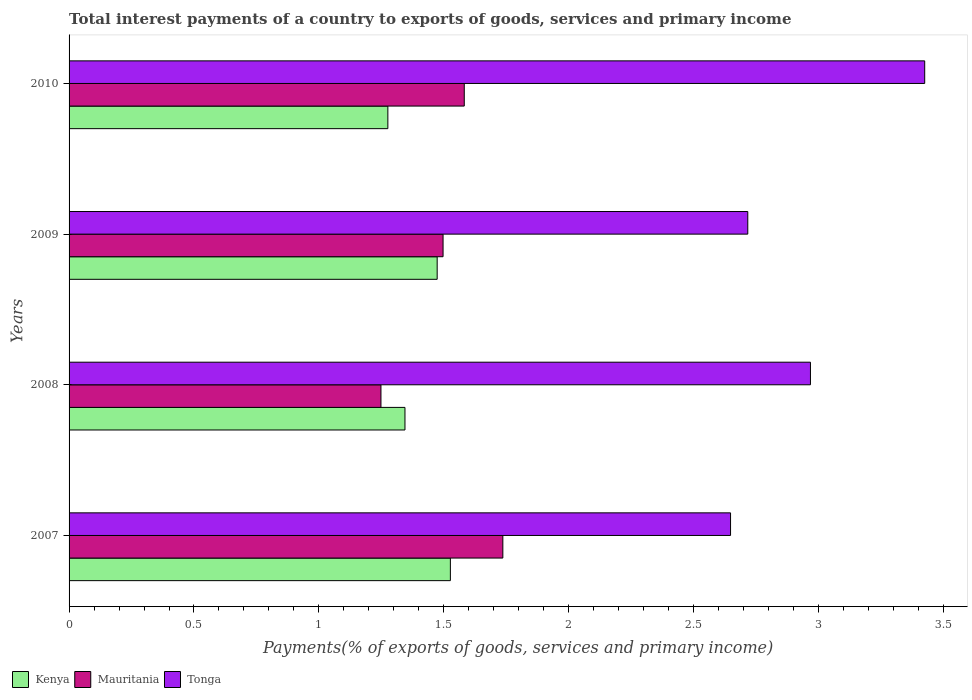How many different coloured bars are there?
Your response must be concise. 3. How many groups of bars are there?
Ensure brevity in your answer.  4. Are the number of bars per tick equal to the number of legend labels?
Give a very brief answer. Yes. Are the number of bars on each tick of the Y-axis equal?
Your answer should be very brief. Yes. How many bars are there on the 4th tick from the bottom?
Provide a succinct answer. 3. In how many cases, is the number of bars for a given year not equal to the number of legend labels?
Ensure brevity in your answer.  0. What is the total interest payments in Tonga in 2010?
Offer a very short reply. 3.43. Across all years, what is the maximum total interest payments in Kenya?
Offer a terse response. 1.53. Across all years, what is the minimum total interest payments in Tonga?
Your response must be concise. 2.65. In which year was the total interest payments in Kenya maximum?
Give a very brief answer. 2007. In which year was the total interest payments in Mauritania minimum?
Provide a short and direct response. 2008. What is the total total interest payments in Kenya in the graph?
Your response must be concise. 5.62. What is the difference between the total interest payments in Kenya in 2007 and that in 2008?
Ensure brevity in your answer.  0.18. What is the difference between the total interest payments in Tonga in 2010 and the total interest payments in Kenya in 2009?
Offer a very short reply. 1.95. What is the average total interest payments in Mauritania per year?
Give a very brief answer. 1.52. In the year 2008, what is the difference between the total interest payments in Tonga and total interest payments in Mauritania?
Give a very brief answer. 1.72. In how many years, is the total interest payments in Kenya greater than 0.8 %?
Give a very brief answer. 4. What is the ratio of the total interest payments in Mauritania in 2008 to that in 2010?
Make the answer very short. 0.79. What is the difference between the highest and the second highest total interest payments in Kenya?
Offer a terse response. 0.05. What is the difference between the highest and the lowest total interest payments in Kenya?
Ensure brevity in your answer.  0.25. What does the 2nd bar from the top in 2008 represents?
Make the answer very short. Mauritania. What does the 1st bar from the bottom in 2008 represents?
Keep it short and to the point. Kenya. How many bars are there?
Your answer should be very brief. 12. Are all the bars in the graph horizontal?
Give a very brief answer. Yes. How many years are there in the graph?
Offer a terse response. 4. What is the difference between two consecutive major ticks on the X-axis?
Offer a terse response. 0.5. Are the values on the major ticks of X-axis written in scientific E-notation?
Offer a very short reply. No. Does the graph contain any zero values?
Your answer should be very brief. No. Does the graph contain grids?
Make the answer very short. No. Where does the legend appear in the graph?
Your answer should be compact. Bottom left. How many legend labels are there?
Give a very brief answer. 3. What is the title of the graph?
Provide a succinct answer. Total interest payments of a country to exports of goods, services and primary income. Does "Bosnia and Herzegovina" appear as one of the legend labels in the graph?
Provide a succinct answer. No. What is the label or title of the X-axis?
Offer a very short reply. Payments(% of exports of goods, services and primary income). What is the Payments(% of exports of goods, services and primary income) of Kenya in 2007?
Keep it short and to the point. 1.53. What is the Payments(% of exports of goods, services and primary income) in Mauritania in 2007?
Your response must be concise. 1.74. What is the Payments(% of exports of goods, services and primary income) in Tonga in 2007?
Your answer should be compact. 2.65. What is the Payments(% of exports of goods, services and primary income) in Kenya in 2008?
Offer a very short reply. 1.34. What is the Payments(% of exports of goods, services and primary income) of Mauritania in 2008?
Make the answer very short. 1.25. What is the Payments(% of exports of goods, services and primary income) in Tonga in 2008?
Your response must be concise. 2.97. What is the Payments(% of exports of goods, services and primary income) of Kenya in 2009?
Your response must be concise. 1.47. What is the Payments(% of exports of goods, services and primary income) in Mauritania in 2009?
Your response must be concise. 1.5. What is the Payments(% of exports of goods, services and primary income) of Tonga in 2009?
Provide a short and direct response. 2.72. What is the Payments(% of exports of goods, services and primary income) of Kenya in 2010?
Ensure brevity in your answer.  1.28. What is the Payments(% of exports of goods, services and primary income) in Mauritania in 2010?
Keep it short and to the point. 1.58. What is the Payments(% of exports of goods, services and primary income) in Tonga in 2010?
Give a very brief answer. 3.43. Across all years, what is the maximum Payments(% of exports of goods, services and primary income) in Kenya?
Offer a very short reply. 1.53. Across all years, what is the maximum Payments(% of exports of goods, services and primary income) in Mauritania?
Keep it short and to the point. 1.74. Across all years, what is the maximum Payments(% of exports of goods, services and primary income) in Tonga?
Give a very brief answer. 3.43. Across all years, what is the minimum Payments(% of exports of goods, services and primary income) of Kenya?
Offer a terse response. 1.28. Across all years, what is the minimum Payments(% of exports of goods, services and primary income) of Mauritania?
Offer a terse response. 1.25. Across all years, what is the minimum Payments(% of exports of goods, services and primary income) in Tonga?
Keep it short and to the point. 2.65. What is the total Payments(% of exports of goods, services and primary income) of Kenya in the graph?
Your answer should be compact. 5.62. What is the total Payments(% of exports of goods, services and primary income) in Mauritania in the graph?
Keep it short and to the point. 6.06. What is the total Payments(% of exports of goods, services and primary income) of Tonga in the graph?
Offer a very short reply. 11.76. What is the difference between the Payments(% of exports of goods, services and primary income) in Kenya in 2007 and that in 2008?
Make the answer very short. 0.18. What is the difference between the Payments(% of exports of goods, services and primary income) of Mauritania in 2007 and that in 2008?
Keep it short and to the point. 0.49. What is the difference between the Payments(% of exports of goods, services and primary income) of Tonga in 2007 and that in 2008?
Offer a very short reply. -0.32. What is the difference between the Payments(% of exports of goods, services and primary income) in Kenya in 2007 and that in 2009?
Give a very brief answer. 0.05. What is the difference between the Payments(% of exports of goods, services and primary income) of Mauritania in 2007 and that in 2009?
Offer a terse response. 0.24. What is the difference between the Payments(% of exports of goods, services and primary income) in Tonga in 2007 and that in 2009?
Your answer should be compact. -0.07. What is the difference between the Payments(% of exports of goods, services and primary income) of Kenya in 2007 and that in 2010?
Provide a short and direct response. 0.25. What is the difference between the Payments(% of exports of goods, services and primary income) in Mauritania in 2007 and that in 2010?
Keep it short and to the point. 0.15. What is the difference between the Payments(% of exports of goods, services and primary income) of Tonga in 2007 and that in 2010?
Provide a succinct answer. -0.78. What is the difference between the Payments(% of exports of goods, services and primary income) in Kenya in 2008 and that in 2009?
Give a very brief answer. -0.13. What is the difference between the Payments(% of exports of goods, services and primary income) of Mauritania in 2008 and that in 2009?
Give a very brief answer. -0.25. What is the difference between the Payments(% of exports of goods, services and primary income) of Tonga in 2008 and that in 2009?
Your response must be concise. 0.25. What is the difference between the Payments(% of exports of goods, services and primary income) in Kenya in 2008 and that in 2010?
Give a very brief answer. 0.07. What is the difference between the Payments(% of exports of goods, services and primary income) of Mauritania in 2008 and that in 2010?
Offer a terse response. -0.33. What is the difference between the Payments(% of exports of goods, services and primary income) of Tonga in 2008 and that in 2010?
Your response must be concise. -0.46. What is the difference between the Payments(% of exports of goods, services and primary income) of Kenya in 2009 and that in 2010?
Your answer should be compact. 0.2. What is the difference between the Payments(% of exports of goods, services and primary income) in Mauritania in 2009 and that in 2010?
Your response must be concise. -0.08. What is the difference between the Payments(% of exports of goods, services and primary income) of Tonga in 2009 and that in 2010?
Your answer should be compact. -0.71. What is the difference between the Payments(% of exports of goods, services and primary income) of Kenya in 2007 and the Payments(% of exports of goods, services and primary income) of Mauritania in 2008?
Give a very brief answer. 0.28. What is the difference between the Payments(% of exports of goods, services and primary income) in Kenya in 2007 and the Payments(% of exports of goods, services and primary income) in Tonga in 2008?
Ensure brevity in your answer.  -1.44. What is the difference between the Payments(% of exports of goods, services and primary income) in Mauritania in 2007 and the Payments(% of exports of goods, services and primary income) in Tonga in 2008?
Offer a terse response. -1.23. What is the difference between the Payments(% of exports of goods, services and primary income) in Kenya in 2007 and the Payments(% of exports of goods, services and primary income) in Mauritania in 2009?
Your response must be concise. 0.03. What is the difference between the Payments(% of exports of goods, services and primary income) in Kenya in 2007 and the Payments(% of exports of goods, services and primary income) in Tonga in 2009?
Your answer should be very brief. -1.19. What is the difference between the Payments(% of exports of goods, services and primary income) of Mauritania in 2007 and the Payments(% of exports of goods, services and primary income) of Tonga in 2009?
Your answer should be compact. -0.98. What is the difference between the Payments(% of exports of goods, services and primary income) of Kenya in 2007 and the Payments(% of exports of goods, services and primary income) of Mauritania in 2010?
Your answer should be compact. -0.06. What is the difference between the Payments(% of exports of goods, services and primary income) in Kenya in 2007 and the Payments(% of exports of goods, services and primary income) in Tonga in 2010?
Provide a short and direct response. -1.9. What is the difference between the Payments(% of exports of goods, services and primary income) in Mauritania in 2007 and the Payments(% of exports of goods, services and primary income) in Tonga in 2010?
Give a very brief answer. -1.69. What is the difference between the Payments(% of exports of goods, services and primary income) in Kenya in 2008 and the Payments(% of exports of goods, services and primary income) in Mauritania in 2009?
Make the answer very short. -0.15. What is the difference between the Payments(% of exports of goods, services and primary income) of Kenya in 2008 and the Payments(% of exports of goods, services and primary income) of Tonga in 2009?
Keep it short and to the point. -1.37. What is the difference between the Payments(% of exports of goods, services and primary income) in Mauritania in 2008 and the Payments(% of exports of goods, services and primary income) in Tonga in 2009?
Give a very brief answer. -1.47. What is the difference between the Payments(% of exports of goods, services and primary income) in Kenya in 2008 and the Payments(% of exports of goods, services and primary income) in Mauritania in 2010?
Offer a very short reply. -0.24. What is the difference between the Payments(% of exports of goods, services and primary income) in Kenya in 2008 and the Payments(% of exports of goods, services and primary income) in Tonga in 2010?
Ensure brevity in your answer.  -2.08. What is the difference between the Payments(% of exports of goods, services and primary income) of Mauritania in 2008 and the Payments(% of exports of goods, services and primary income) of Tonga in 2010?
Make the answer very short. -2.18. What is the difference between the Payments(% of exports of goods, services and primary income) of Kenya in 2009 and the Payments(% of exports of goods, services and primary income) of Mauritania in 2010?
Your answer should be compact. -0.11. What is the difference between the Payments(% of exports of goods, services and primary income) in Kenya in 2009 and the Payments(% of exports of goods, services and primary income) in Tonga in 2010?
Give a very brief answer. -1.95. What is the difference between the Payments(% of exports of goods, services and primary income) in Mauritania in 2009 and the Payments(% of exports of goods, services and primary income) in Tonga in 2010?
Provide a short and direct response. -1.93. What is the average Payments(% of exports of goods, services and primary income) in Kenya per year?
Make the answer very short. 1.41. What is the average Payments(% of exports of goods, services and primary income) in Mauritania per year?
Your answer should be very brief. 1.52. What is the average Payments(% of exports of goods, services and primary income) of Tonga per year?
Keep it short and to the point. 2.94. In the year 2007, what is the difference between the Payments(% of exports of goods, services and primary income) of Kenya and Payments(% of exports of goods, services and primary income) of Mauritania?
Keep it short and to the point. -0.21. In the year 2007, what is the difference between the Payments(% of exports of goods, services and primary income) in Kenya and Payments(% of exports of goods, services and primary income) in Tonga?
Give a very brief answer. -1.12. In the year 2007, what is the difference between the Payments(% of exports of goods, services and primary income) in Mauritania and Payments(% of exports of goods, services and primary income) in Tonga?
Give a very brief answer. -0.91. In the year 2008, what is the difference between the Payments(% of exports of goods, services and primary income) of Kenya and Payments(% of exports of goods, services and primary income) of Mauritania?
Make the answer very short. 0.1. In the year 2008, what is the difference between the Payments(% of exports of goods, services and primary income) in Kenya and Payments(% of exports of goods, services and primary income) in Tonga?
Make the answer very short. -1.62. In the year 2008, what is the difference between the Payments(% of exports of goods, services and primary income) in Mauritania and Payments(% of exports of goods, services and primary income) in Tonga?
Provide a short and direct response. -1.72. In the year 2009, what is the difference between the Payments(% of exports of goods, services and primary income) in Kenya and Payments(% of exports of goods, services and primary income) in Mauritania?
Make the answer very short. -0.02. In the year 2009, what is the difference between the Payments(% of exports of goods, services and primary income) in Kenya and Payments(% of exports of goods, services and primary income) in Tonga?
Offer a very short reply. -1.24. In the year 2009, what is the difference between the Payments(% of exports of goods, services and primary income) in Mauritania and Payments(% of exports of goods, services and primary income) in Tonga?
Offer a terse response. -1.22. In the year 2010, what is the difference between the Payments(% of exports of goods, services and primary income) in Kenya and Payments(% of exports of goods, services and primary income) in Mauritania?
Your answer should be compact. -0.31. In the year 2010, what is the difference between the Payments(% of exports of goods, services and primary income) of Kenya and Payments(% of exports of goods, services and primary income) of Tonga?
Offer a very short reply. -2.15. In the year 2010, what is the difference between the Payments(% of exports of goods, services and primary income) in Mauritania and Payments(% of exports of goods, services and primary income) in Tonga?
Keep it short and to the point. -1.84. What is the ratio of the Payments(% of exports of goods, services and primary income) of Kenya in 2007 to that in 2008?
Give a very brief answer. 1.14. What is the ratio of the Payments(% of exports of goods, services and primary income) of Mauritania in 2007 to that in 2008?
Ensure brevity in your answer.  1.39. What is the ratio of the Payments(% of exports of goods, services and primary income) in Tonga in 2007 to that in 2008?
Keep it short and to the point. 0.89. What is the ratio of the Payments(% of exports of goods, services and primary income) of Kenya in 2007 to that in 2009?
Ensure brevity in your answer.  1.04. What is the ratio of the Payments(% of exports of goods, services and primary income) of Mauritania in 2007 to that in 2009?
Ensure brevity in your answer.  1.16. What is the ratio of the Payments(% of exports of goods, services and primary income) of Tonga in 2007 to that in 2009?
Offer a terse response. 0.97. What is the ratio of the Payments(% of exports of goods, services and primary income) in Kenya in 2007 to that in 2010?
Provide a succinct answer. 1.2. What is the ratio of the Payments(% of exports of goods, services and primary income) in Mauritania in 2007 to that in 2010?
Your answer should be compact. 1.1. What is the ratio of the Payments(% of exports of goods, services and primary income) in Tonga in 2007 to that in 2010?
Offer a very short reply. 0.77. What is the ratio of the Payments(% of exports of goods, services and primary income) of Kenya in 2008 to that in 2009?
Give a very brief answer. 0.91. What is the ratio of the Payments(% of exports of goods, services and primary income) in Mauritania in 2008 to that in 2009?
Provide a short and direct response. 0.83. What is the ratio of the Payments(% of exports of goods, services and primary income) in Tonga in 2008 to that in 2009?
Offer a terse response. 1.09. What is the ratio of the Payments(% of exports of goods, services and primary income) of Kenya in 2008 to that in 2010?
Keep it short and to the point. 1.05. What is the ratio of the Payments(% of exports of goods, services and primary income) in Mauritania in 2008 to that in 2010?
Offer a terse response. 0.79. What is the ratio of the Payments(% of exports of goods, services and primary income) of Tonga in 2008 to that in 2010?
Provide a short and direct response. 0.87. What is the ratio of the Payments(% of exports of goods, services and primary income) in Kenya in 2009 to that in 2010?
Provide a succinct answer. 1.15. What is the ratio of the Payments(% of exports of goods, services and primary income) of Mauritania in 2009 to that in 2010?
Your response must be concise. 0.95. What is the ratio of the Payments(% of exports of goods, services and primary income) in Tonga in 2009 to that in 2010?
Your answer should be compact. 0.79. What is the difference between the highest and the second highest Payments(% of exports of goods, services and primary income) in Kenya?
Keep it short and to the point. 0.05. What is the difference between the highest and the second highest Payments(% of exports of goods, services and primary income) in Mauritania?
Provide a succinct answer. 0.15. What is the difference between the highest and the second highest Payments(% of exports of goods, services and primary income) in Tonga?
Give a very brief answer. 0.46. What is the difference between the highest and the lowest Payments(% of exports of goods, services and primary income) in Kenya?
Ensure brevity in your answer.  0.25. What is the difference between the highest and the lowest Payments(% of exports of goods, services and primary income) of Mauritania?
Provide a succinct answer. 0.49. What is the difference between the highest and the lowest Payments(% of exports of goods, services and primary income) of Tonga?
Provide a succinct answer. 0.78. 